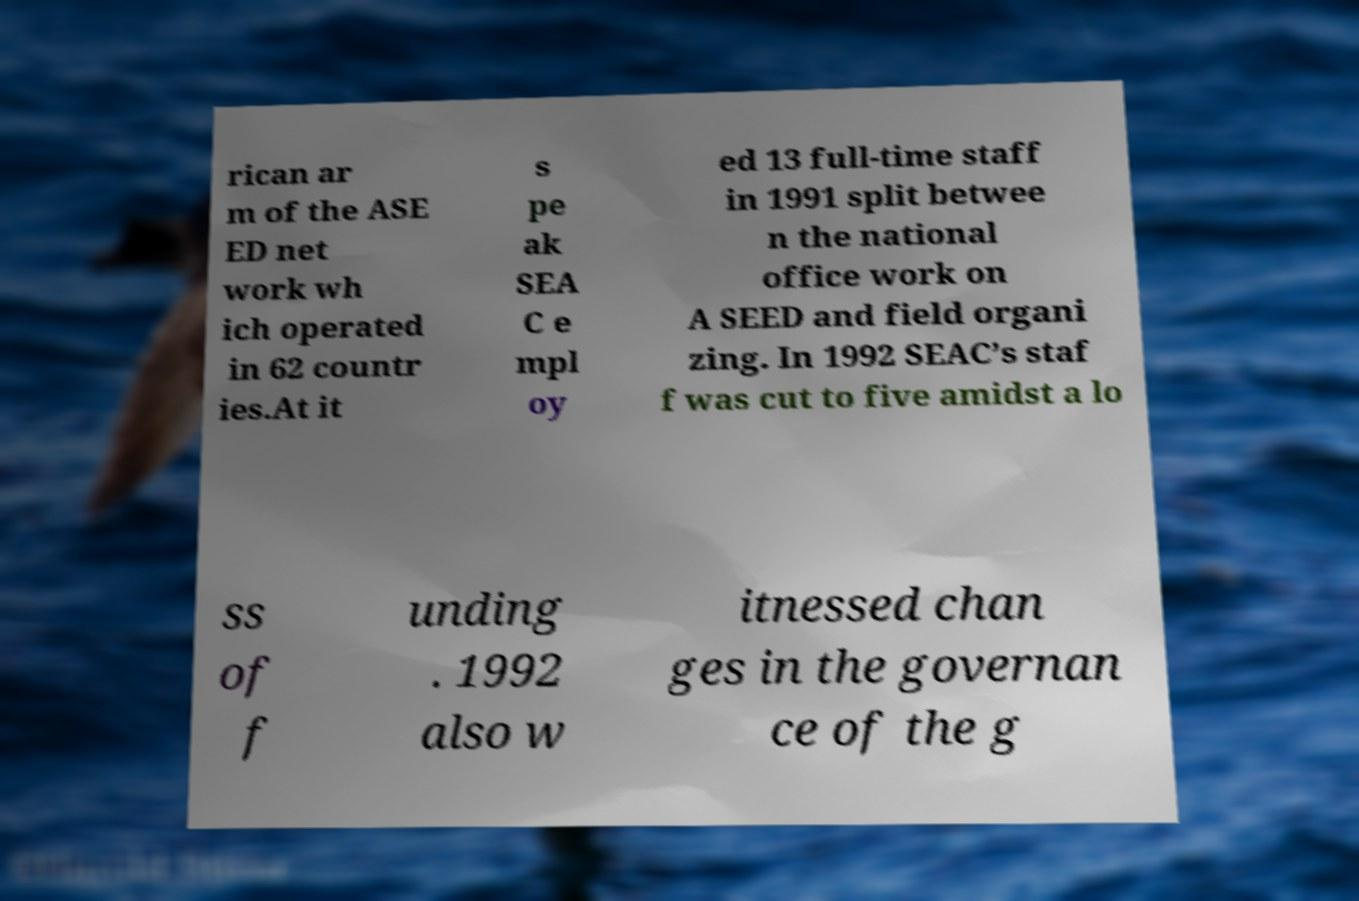For documentation purposes, I need the text within this image transcribed. Could you provide that? rican ar m of the ASE ED net work wh ich operated in 62 countr ies.At it s pe ak SEA C e mpl oy ed 13 full-time staff in 1991 split betwee n the national office work on A SEED and field organi zing. In 1992 SEAC’s staf f was cut to five amidst a lo ss of f unding . 1992 also w itnessed chan ges in the governan ce of the g 